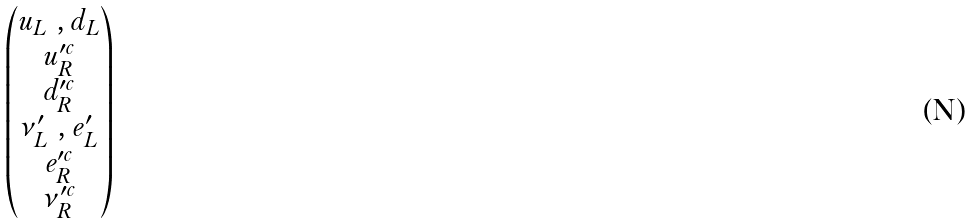<formula> <loc_0><loc_0><loc_500><loc_500>\begin{pmatrix} u _ { L } \ , d _ { L } \\ u ^ { \prime c } _ { R } \\ d _ { R } ^ { \prime c } \\ \nu ^ { \prime } _ { L } \ , e ^ { \prime } _ { L } \\ e _ { R } ^ { \prime c } \\ \nu _ { R } ^ { \prime c } \\ \end{pmatrix}</formula> 